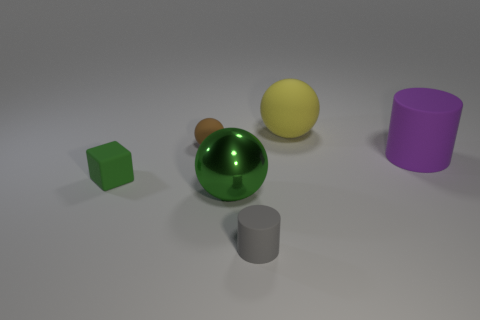Imagine these objects are part of a puzzle. Can you propose a way to solve it? If we consider these objects as part of a puzzle, one possible challenge could be to arrange them by shape or color. For instance, sorting them into groups such that all spheres are on one side and cylinders on the other, or arranging them by color shades from light to dark. 